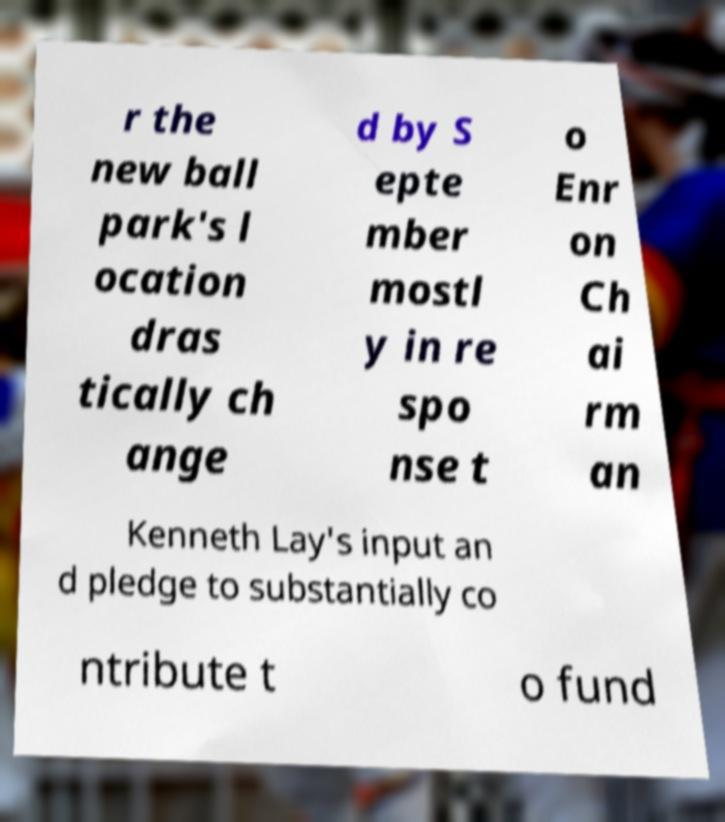Could you extract and type out the text from this image? r the new ball park's l ocation dras tically ch ange d by S epte mber mostl y in re spo nse t o Enr on Ch ai rm an Kenneth Lay's input an d pledge to substantially co ntribute t o fund 